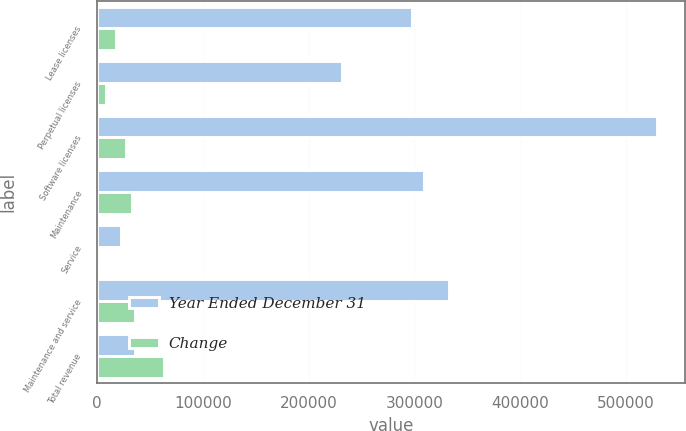Convert chart to OTSL. <chart><loc_0><loc_0><loc_500><loc_500><stacked_bar_chart><ecel><fcel>Lease licenses<fcel>Perpetual licenses<fcel>Software licenses<fcel>Maintenance<fcel>Service<fcel>Maintenance and service<fcel>Total revenue<nl><fcel>Year Ended December 31<fcel>297658<fcel>231286<fcel>528944<fcel>309085<fcel>23231<fcel>332316<fcel>36168<nl><fcel>Change<fcel>18375<fcel>8699<fcel>27074<fcel>33587<fcel>2581<fcel>36168<fcel>63242<nl></chart> 